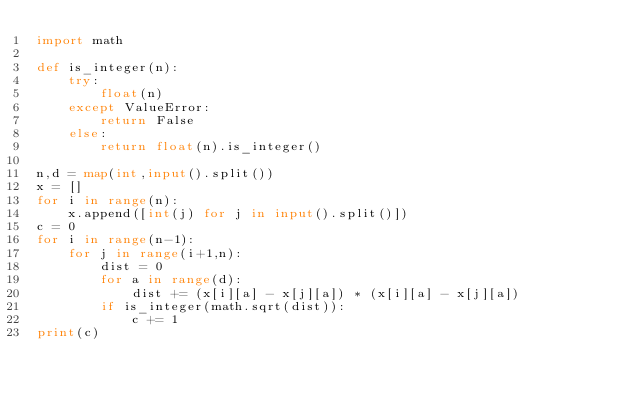Convert code to text. <code><loc_0><loc_0><loc_500><loc_500><_Python_>import math

def is_integer(n):
    try:
        float(n)
    except ValueError:
        return False
    else:
        return float(n).is_integer()

n,d = map(int,input().split())
x = []
for i in range(n):
    x.append([int(j) for j in input().split()])
c = 0
for i in range(n-1):
    for j in range(i+1,n):
        dist = 0
        for a in range(d):
            dist += (x[i][a] - x[j][a]) * (x[i][a] - x[j][a])
        if is_integer(math.sqrt(dist)):
            c += 1
print(c)</code> 